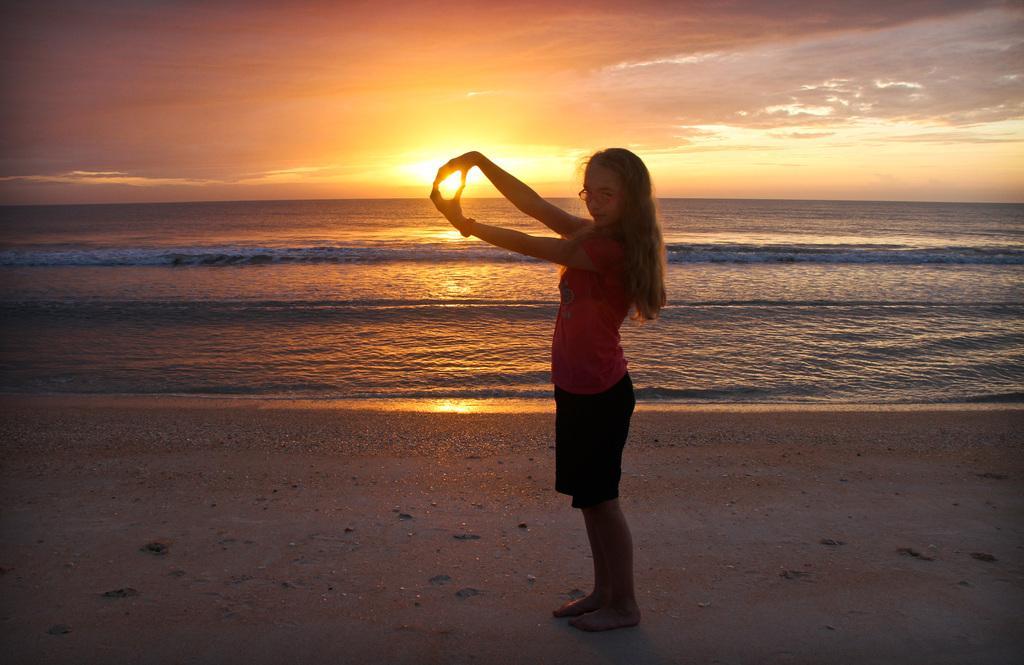How would you summarize this image in a sentence or two? In this image I can see a person is standing. Back I can see the water and sky is in orange, yellow and white color. 